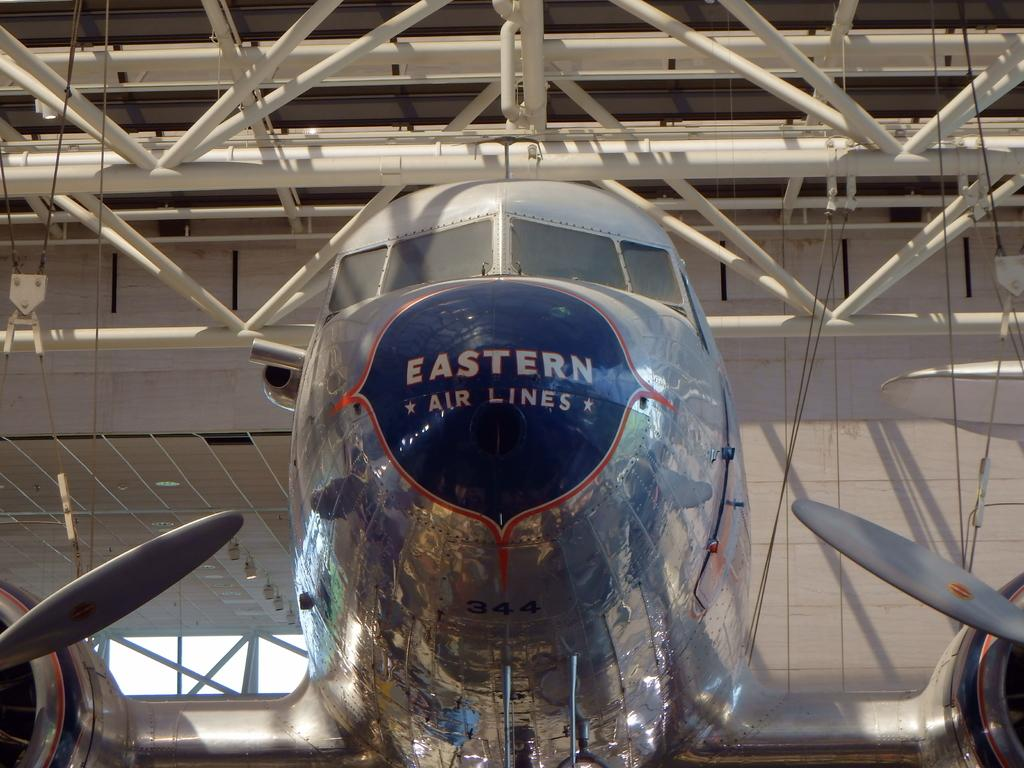<image>
Offer a succinct explanation of the picture presented. An Eastern Air Lines plane sits in an airplane hanger. 